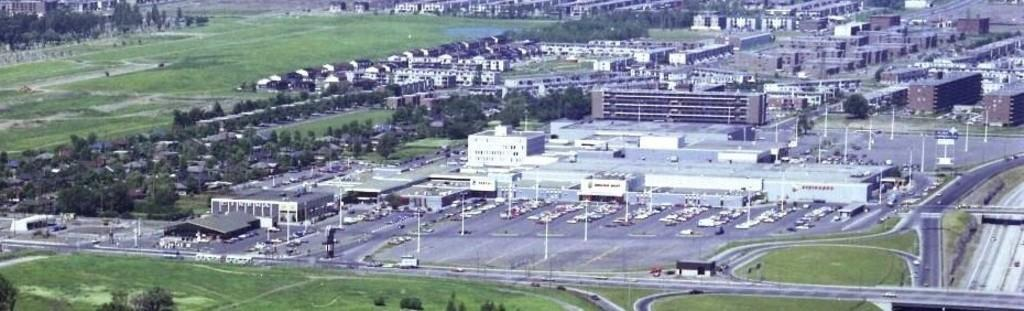What type of structures can be seen in the image? There are many buildings in the image. What feature do the buildings have? The buildings have windows. What type of vegetation is visible in the image? There is grass visible in the image, and surrounding trees are present. What type of pathway is in the image? There is a road in the image. What are the poles in the image used for? The poles in the image are likely used for supporting lights or other infrastructure. What can be seen on the poles? There are lights in the image. What type of sack can be seen filled with cakes in the image? There is no sack filled with cakes present in the image. How many bags of popcorn are visible in the image? There are no bags of popcorn visible in the image. 